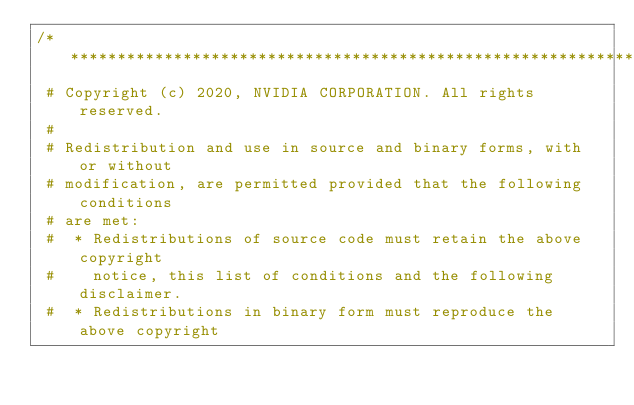Convert code to text. <code><loc_0><loc_0><loc_500><loc_500><_C++_>/***************************************************************************
 # Copyright (c) 2020, NVIDIA CORPORATION. All rights reserved.
 #
 # Redistribution and use in source and binary forms, with or without
 # modification, are permitted provided that the following conditions
 # are met:
 #  * Redistributions of source code must retain the above copyright
 #    notice, this list of conditions and the following disclaimer.
 #  * Redistributions in binary form must reproduce the above copyright</code> 